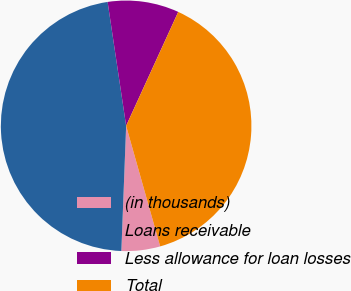Convert chart to OTSL. <chart><loc_0><loc_0><loc_500><loc_500><pie_chart><fcel>(in thousands)<fcel>Loans receivable<fcel>Less allowance for loan losses<fcel>Total<nl><fcel>4.99%<fcel>47.03%<fcel>9.19%<fcel>38.79%<nl></chart> 